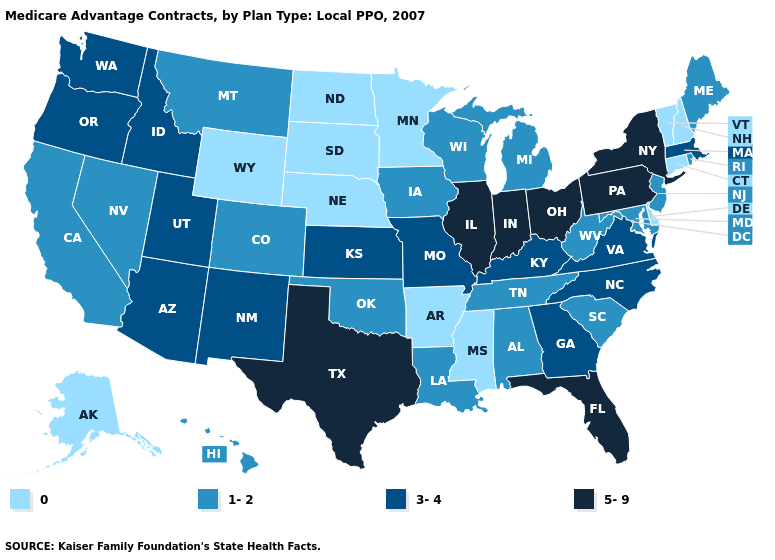What is the lowest value in the USA?
Quick response, please. 0. Which states hav the highest value in the West?
Answer briefly. Arizona, Idaho, New Mexico, Oregon, Utah, Washington. Does South Carolina have the highest value in the USA?
Give a very brief answer. No. Does the first symbol in the legend represent the smallest category?
Short answer required. Yes. What is the highest value in the USA?
Give a very brief answer. 5-9. What is the value of Mississippi?
Quick response, please. 0. What is the value of California?
Be succinct. 1-2. What is the value of Utah?
Write a very short answer. 3-4. Does Minnesota have the highest value in the MidWest?
Concise answer only. No. Name the states that have a value in the range 0?
Be succinct. Alaska, Arkansas, Connecticut, Delaware, Minnesota, Mississippi, North Dakota, Nebraska, New Hampshire, South Dakota, Vermont, Wyoming. Among the states that border Montana , does South Dakota have the highest value?
Write a very short answer. No. What is the value of South Dakota?
Keep it brief. 0. How many symbols are there in the legend?
Answer briefly. 4. Which states hav the highest value in the Northeast?
Short answer required. New York, Pennsylvania. Does Wisconsin have the lowest value in the USA?
Short answer required. No. 